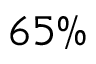Convert formula to latex. <formula><loc_0><loc_0><loc_500><loc_500>6 5 \%</formula> 